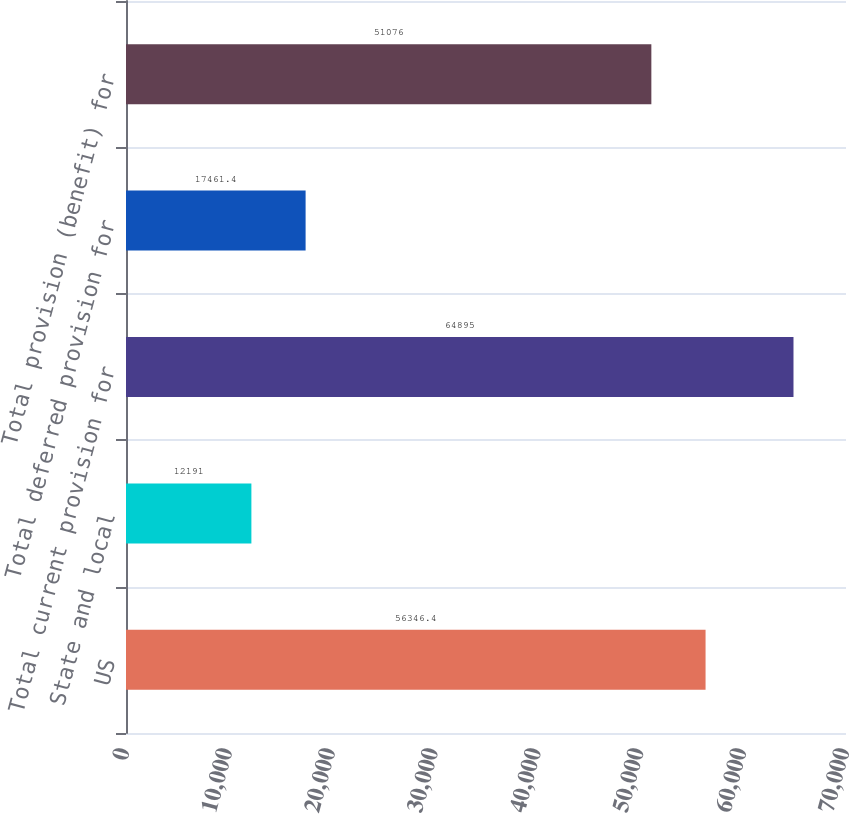<chart> <loc_0><loc_0><loc_500><loc_500><bar_chart><fcel>US<fcel>State and local<fcel>Total current provision for<fcel>Total deferred provision for<fcel>Total provision (benefit) for<nl><fcel>56346.4<fcel>12191<fcel>64895<fcel>17461.4<fcel>51076<nl></chart> 